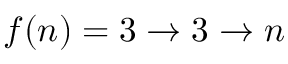<formula> <loc_0><loc_0><loc_500><loc_500>f ( n ) = 3 \rightarrow 3 \rightarrow n</formula> 